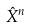Convert formula to latex. <formula><loc_0><loc_0><loc_500><loc_500>\hat { X } ^ { n }</formula> 